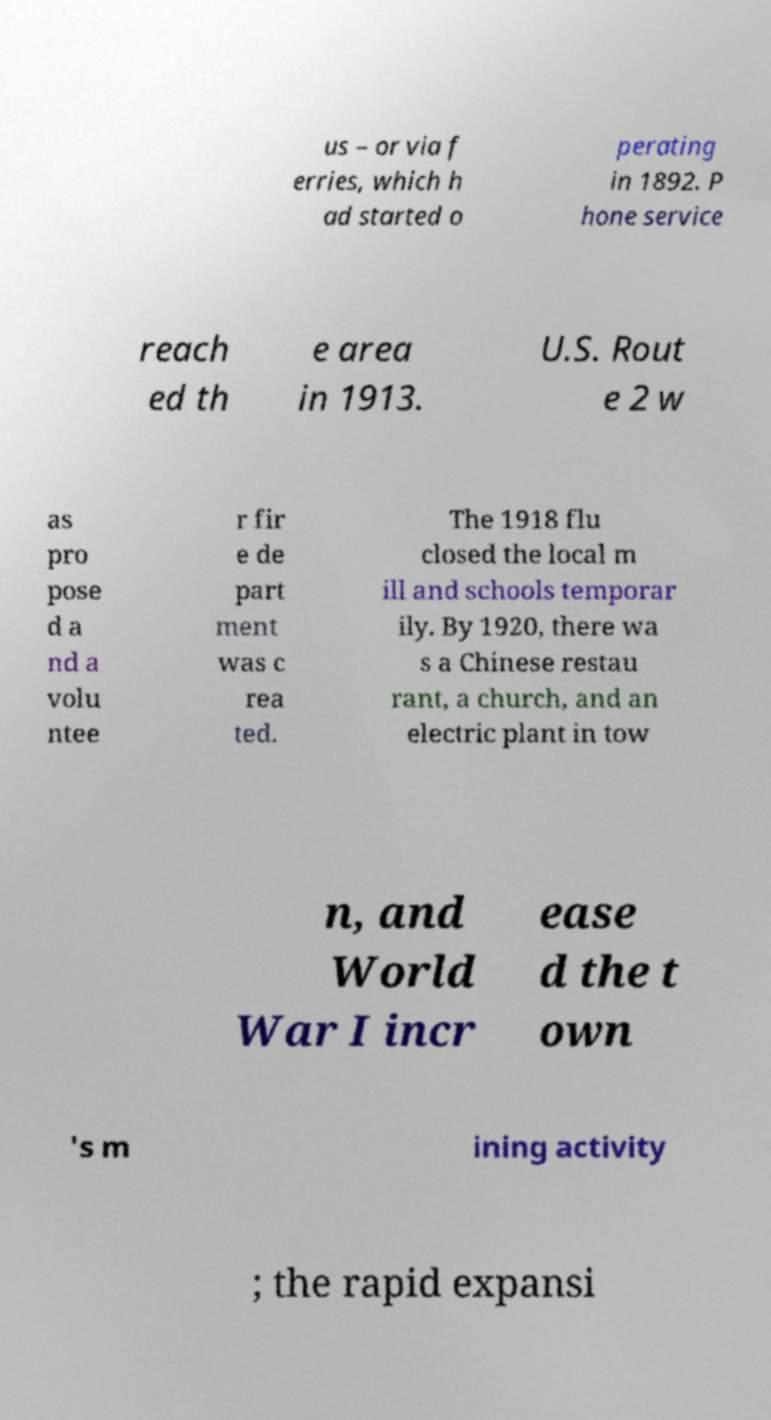Can you accurately transcribe the text from the provided image for me? us – or via f erries, which h ad started o perating in 1892. P hone service reach ed th e area in 1913. U.S. Rout e 2 w as pro pose d a nd a volu ntee r fir e de part ment was c rea ted. The 1918 flu closed the local m ill and schools temporar ily. By 1920, there wa s a Chinese restau rant, a church, and an electric plant in tow n, and World War I incr ease d the t own 's m ining activity ; the rapid expansi 